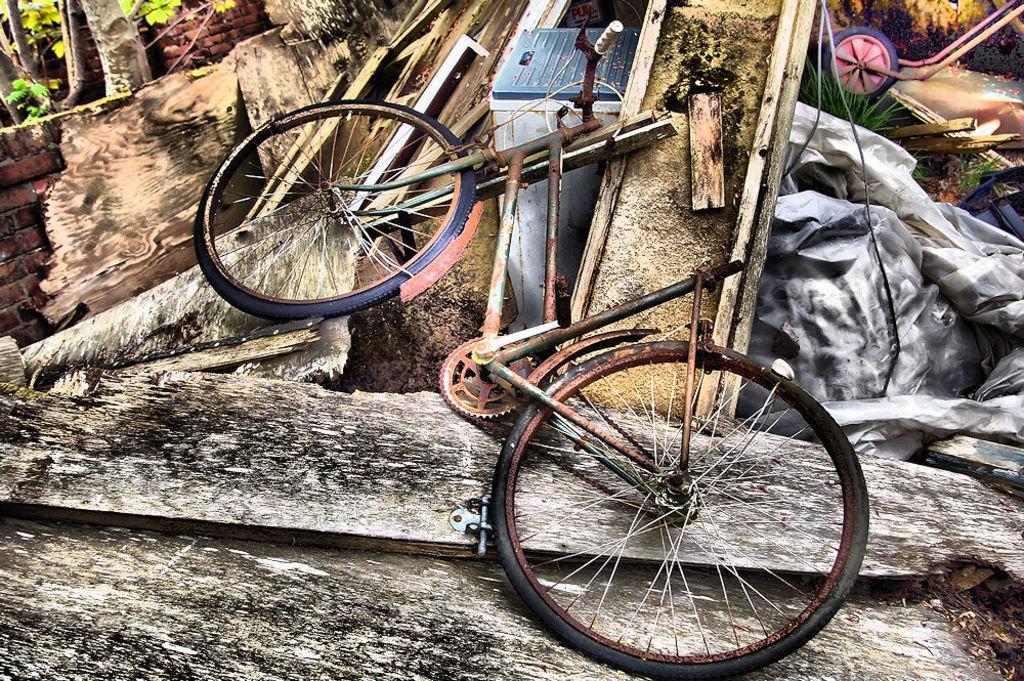How would you summarize this image in a sentence or two? In this picture I can see a bicycle, grass, leaves, tree trunks and some other objects. 